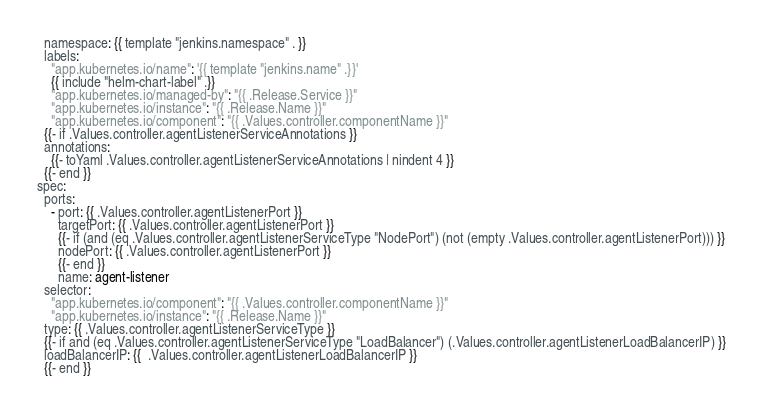Convert code to text. <code><loc_0><loc_0><loc_500><loc_500><_YAML_>  namespace: {{ template "jenkins.namespace" . }}
  labels:
    "app.kubernetes.io/name": '{{ template "jenkins.name" .}}'
    {{ include "helm-chart-label" .}}
    "app.kubernetes.io/managed-by": "{{ .Release.Service }}"
    "app.kubernetes.io/instance": "{{ .Release.Name }}"
    "app.kubernetes.io/component": "{{ .Values.controller.componentName }}"
  {{- if .Values.controller.agentListenerServiceAnnotations }}
  annotations:
    {{- toYaml .Values.controller.agentListenerServiceAnnotations | nindent 4 }}
  {{- end }}
spec:
  ports:
    - port: {{ .Values.controller.agentListenerPort }}
      targetPort: {{ .Values.controller.agentListenerPort }}
      {{- if (and (eq .Values.controller.agentListenerServiceType "NodePort") (not (empty .Values.controller.agentListenerPort))) }}
      nodePort: {{ .Values.controller.agentListenerPort }}
      {{- end }}
      name: agent-listener
  selector:
    "app.kubernetes.io/component": "{{ .Values.controller.componentName }}"
    "app.kubernetes.io/instance": "{{ .Release.Name }}"
  type: {{ .Values.controller.agentListenerServiceType }}
  {{- if and (eq .Values.controller.agentListenerServiceType "LoadBalancer") (.Values.controller.agentListenerLoadBalancerIP) }}
  loadBalancerIP: {{  .Values.controller.agentListenerLoadBalancerIP }}
  {{- end }}
</code> 